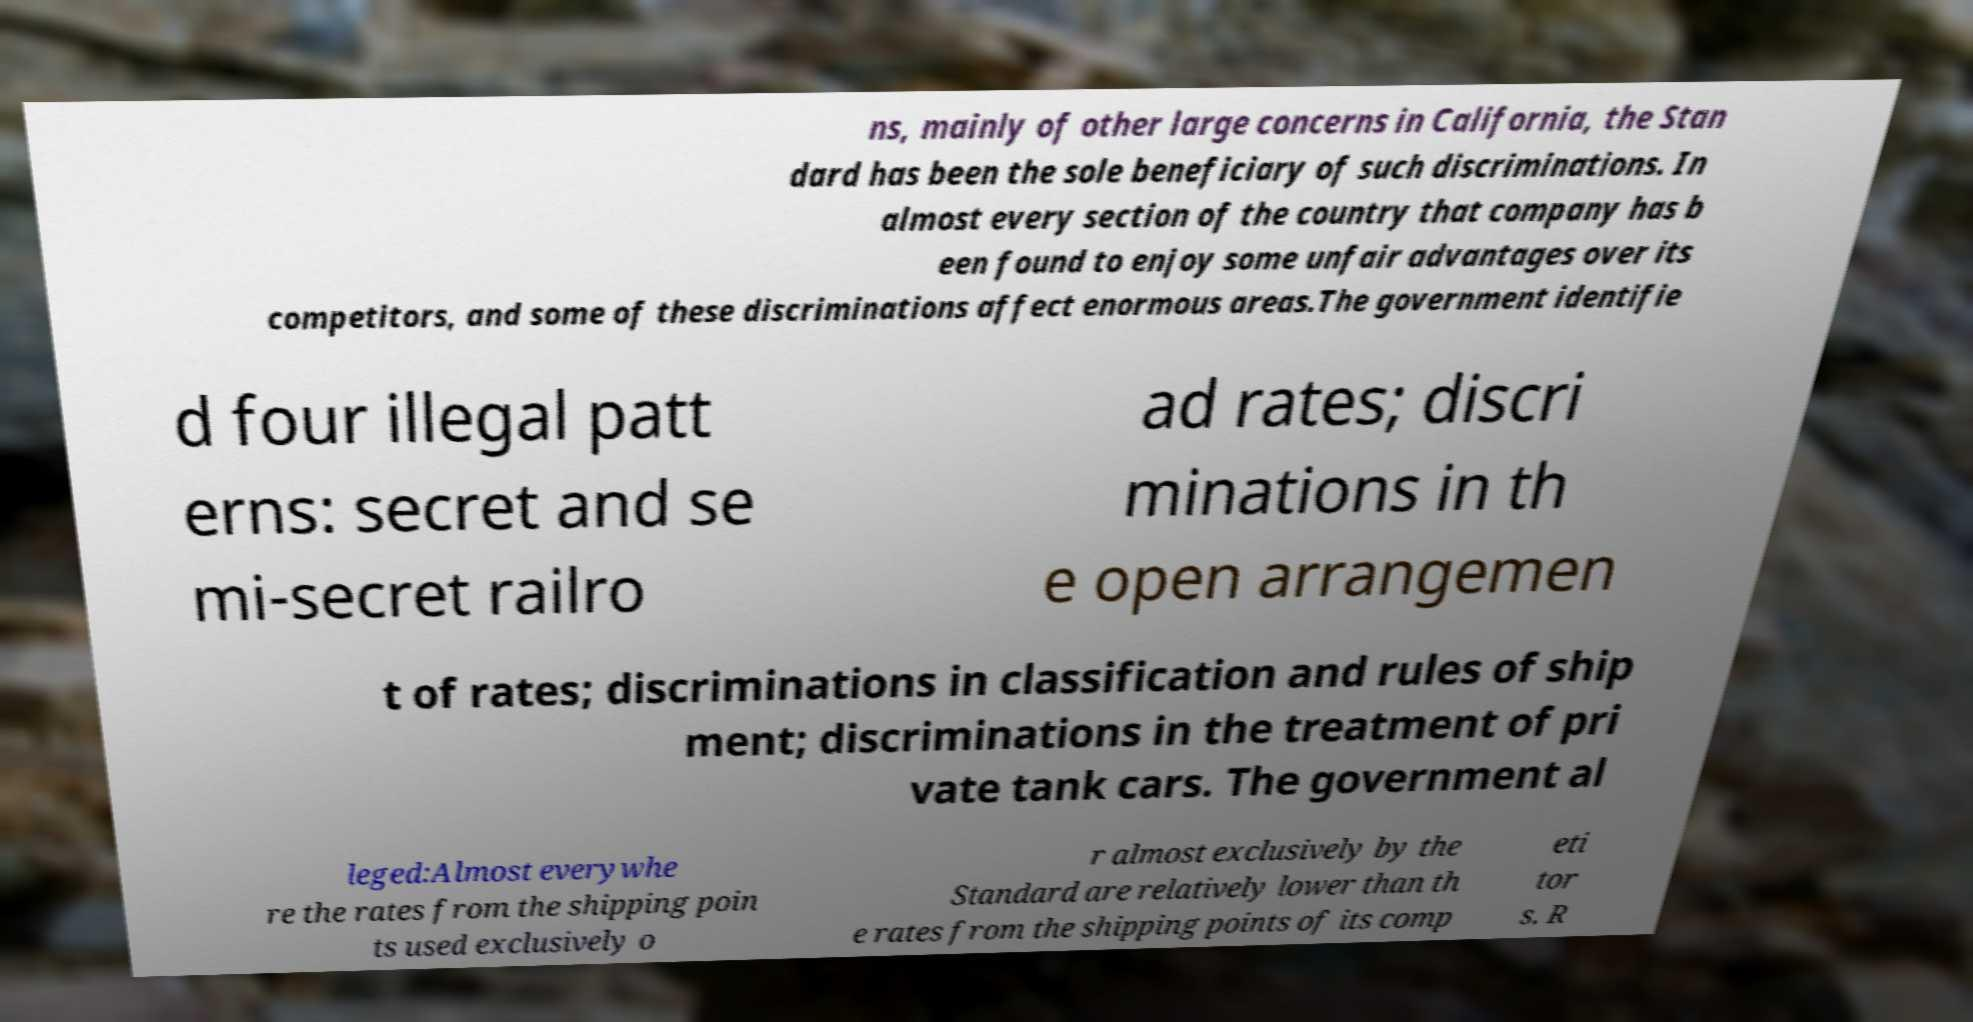Could you extract and type out the text from this image? ns, mainly of other large concerns in California, the Stan dard has been the sole beneficiary of such discriminations. In almost every section of the country that company has b een found to enjoy some unfair advantages over its competitors, and some of these discriminations affect enormous areas.The government identifie d four illegal patt erns: secret and se mi-secret railro ad rates; discri minations in th e open arrangemen t of rates; discriminations in classification and rules of ship ment; discriminations in the treatment of pri vate tank cars. The government al leged:Almost everywhe re the rates from the shipping poin ts used exclusively o r almost exclusively by the Standard are relatively lower than th e rates from the shipping points of its comp eti tor s. R 